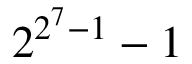<formula> <loc_0><loc_0><loc_500><loc_500>2 ^ { 2 ^ { 7 } - 1 } - 1</formula> 